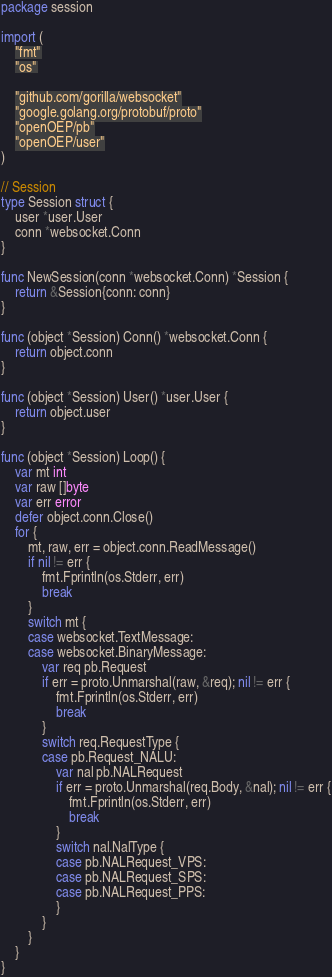<code> <loc_0><loc_0><loc_500><loc_500><_Go_>package session

import (
	"fmt"
	"os"

	"github.com/gorilla/websocket"
	"google.golang.org/protobuf/proto"
	"openOEP/pb"
	"openOEP/user"
)

// Session
type Session struct {
	user *user.User
	conn *websocket.Conn
}

func NewSession(conn *websocket.Conn) *Session {
	return &Session{conn: conn}
}

func (object *Session) Conn() *websocket.Conn {
	return object.conn
}

func (object *Session) User() *user.User {
	return object.user
}

func (object *Session) Loop() {
	var mt int
	var raw []byte
	var err error
	defer object.conn.Close()
	for {
		mt, raw, err = object.conn.ReadMessage()
		if nil != err {
			fmt.Fprintln(os.Stderr, err)
			break
		}
		switch mt {
		case websocket.TextMessage:
		case websocket.BinaryMessage:
			var req pb.Request
			if err = proto.Unmarshal(raw, &req); nil != err {
				fmt.Fprintln(os.Stderr, err)
				break
			}
			switch req.RequestType {
			case pb.Request_NALU:
				var nal pb.NALRequest
				if err = proto.Unmarshal(req.Body, &nal); nil != err {
					fmt.Fprintln(os.Stderr, err)
					break
				}
				switch nal.NalType {
				case pb.NALRequest_VPS:
				case pb.NALRequest_SPS:
				case pb.NALRequest_PPS:
				}
			}
		}
	}
}
</code> 